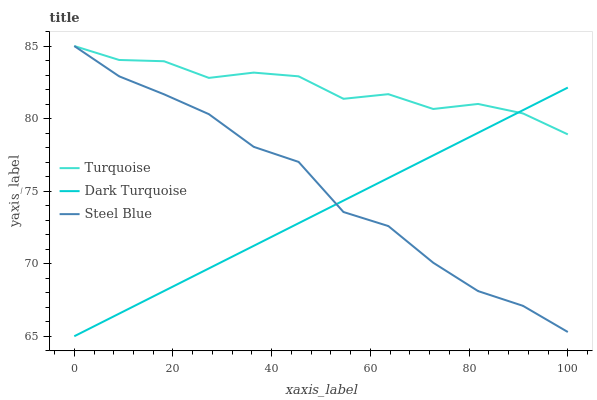Does Dark Turquoise have the minimum area under the curve?
Answer yes or no. Yes. Does Turquoise have the maximum area under the curve?
Answer yes or no. Yes. Does Steel Blue have the minimum area under the curve?
Answer yes or no. No. Does Steel Blue have the maximum area under the curve?
Answer yes or no. No. Is Dark Turquoise the smoothest?
Answer yes or no. Yes. Is Steel Blue the roughest?
Answer yes or no. Yes. Is Turquoise the smoothest?
Answer yes or no. No. Is Turquoise the roughest?
Answer yes or no. No. Does Dark Turquoise have the lowest value?
Answer yes or no. Yes. Does Steel Blue have the lowest value?
Answer yes or no. No. Does Steel Blue have the highest value?
Answer yes or no. Yes. Does Turquoise intersect Steel Blue?
Answer yes or no. Yes. Is Turquoise less than Steel Blue?
Answer yes or no. No. Is Turquoise greater than Steel Blue?
Answer yes or no. No. 